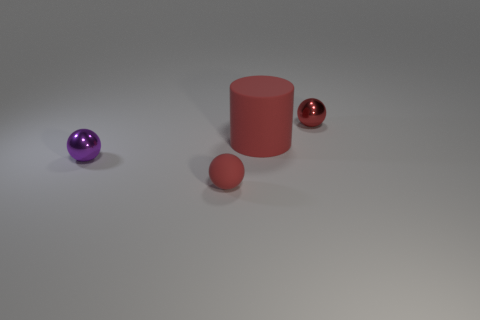What shape is the rubber thing that is the same color as the tiny rubber ball?
Make the answer very short. Cylinder. The shiny object that is the same color as the large cylinder is what size?
Your answer should be compact. Small. Are there any tiny things to the right of the red rubber cylinder?
Offer a very short reply. Yes. What is the size of the purple metallic thing that is the same shape as the small red rubber object?
Offer a terse response. Small. Is there anything else that has the same size as the red metal ball?
Offer a terse response. Yes. Is the purple thing the same shape as the small rubber thing?
Your response must be concise. Yes. What is the size of the ball that is on the left side of the red object that is in front of the large red cylinder?
Give a very brief answer. Small. What is the color of the other matte object that is the same shape as the purple thing?
Offer a terse response. Red. What number of small balls have the same color as the large cylinder?
Your response must be concise. 2. How big is the purple shiny thing?
Ensure brevity in your answer.  Small. 